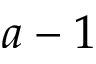<formula> <loc_0><loc_0><loc_500><loc_500>a - 1</formula> 